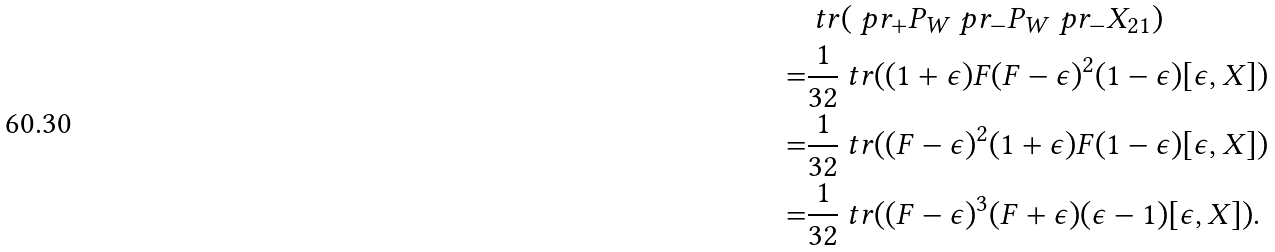<formula> <loc_0><loc_0><loc_500><loc_500>& \ t r ( \ p r _ { + } P _ { W } \ p r _ { - } P _ { W } \ p r _ { - } X _ { 2 1 } ) \\ = & \frac { 1 } { 3 2 } \ t r ( ( 1 + \epsilon ) F ( F - \epsilon ) ^ { 2 } ( 1 - \epsilon ) [ \epsilon , X ] ) \\ = & \frac { 1 } { 3 2 } \ t r ( ( F - \epsilon ) ^ { 2 } ( 1 + \epsilon ) F ( 1 - \epsilon ) [ \epsilon , X ] ) \\ = & \frac { 1 } { 3 2 } \ t r ( ( F - \epsilon ) ^ { 3 } ( F + \epsilon ) ( \epsilon - 1 ) [ \epsilon , X ] ) .</formula> 